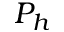Convert formula to latex. <formula><loc_0><loc_0><loc_500><loc_500>P _ { h }</formula> 